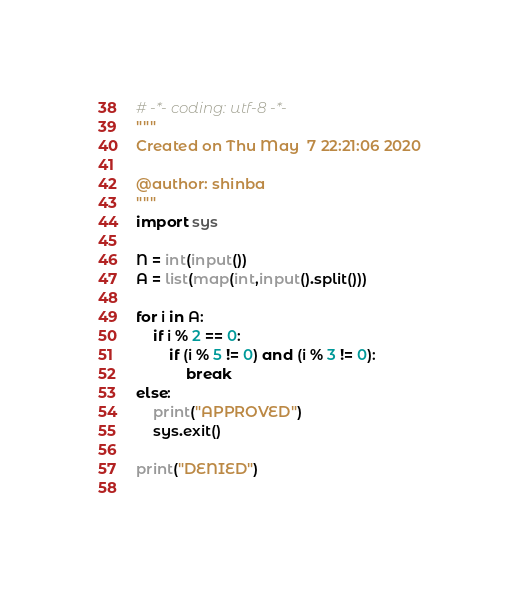<code> <loc_0><loc_0><loc_500><loc_500><_Python_># -*- coding: utf-8 -*-
"""
Created on Thu May  7 22:21:06 2020

@author: shinba
"""
import sys

N = int(input())
A = list(map(int,input().split()))

for i in A:
    if i % 2 == 0:
        if (i % 5 != 0) and (i % 3 != 0):
            break
else:
    print("APPROVED")
    sys.exit()
    
print("DENIED")
            
</code> 